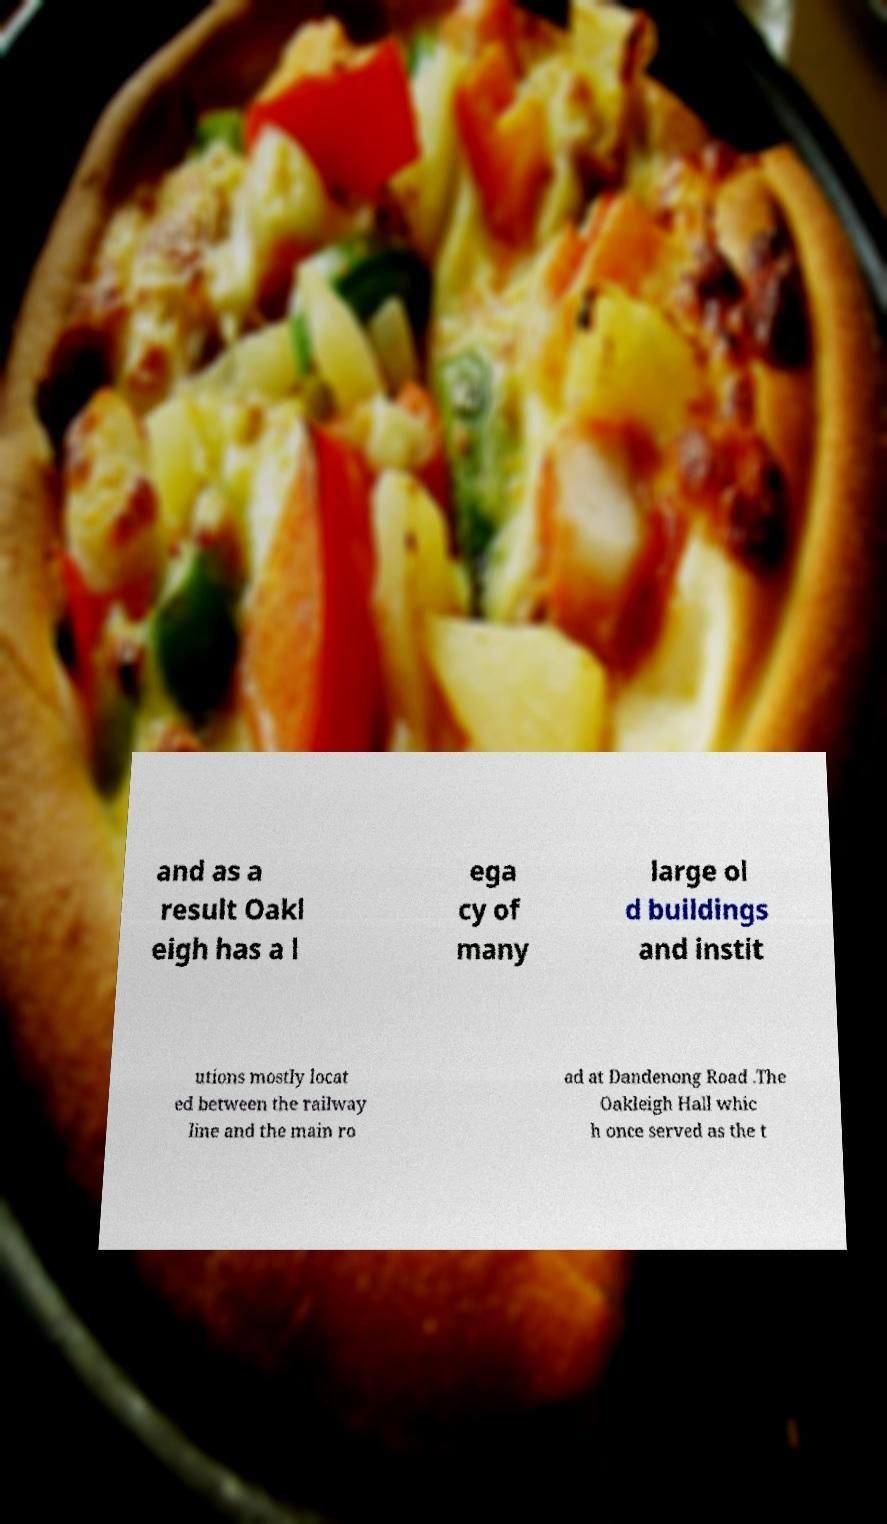Can you read and provide the text displayed in the image?This photo seems to have some interesting text. Can you extract and type it out for me? and as a result Oakl eigh has a l ega cy of many large ol d buildings and instit utions mostly locat ed between the railway line and the main ro ad at Dandenong Road .The Oakleigh Hall whic h once served as the t 